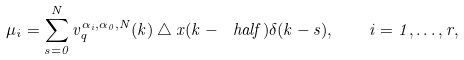Convert formula to latex. <formula><loc_0><loc_0><loc_500><loc_500>\mu _ { i } = \sum _ { s = 0 } ^ { N } v ^ { \alpha _ { i } , \alpha _ { 0 } , N } _ { q } ( k ) \bigtriangleup x ( k - \ h a l f ) \delta ( k - s ) , \quad i = 1 , \dots , r ,</formula> 